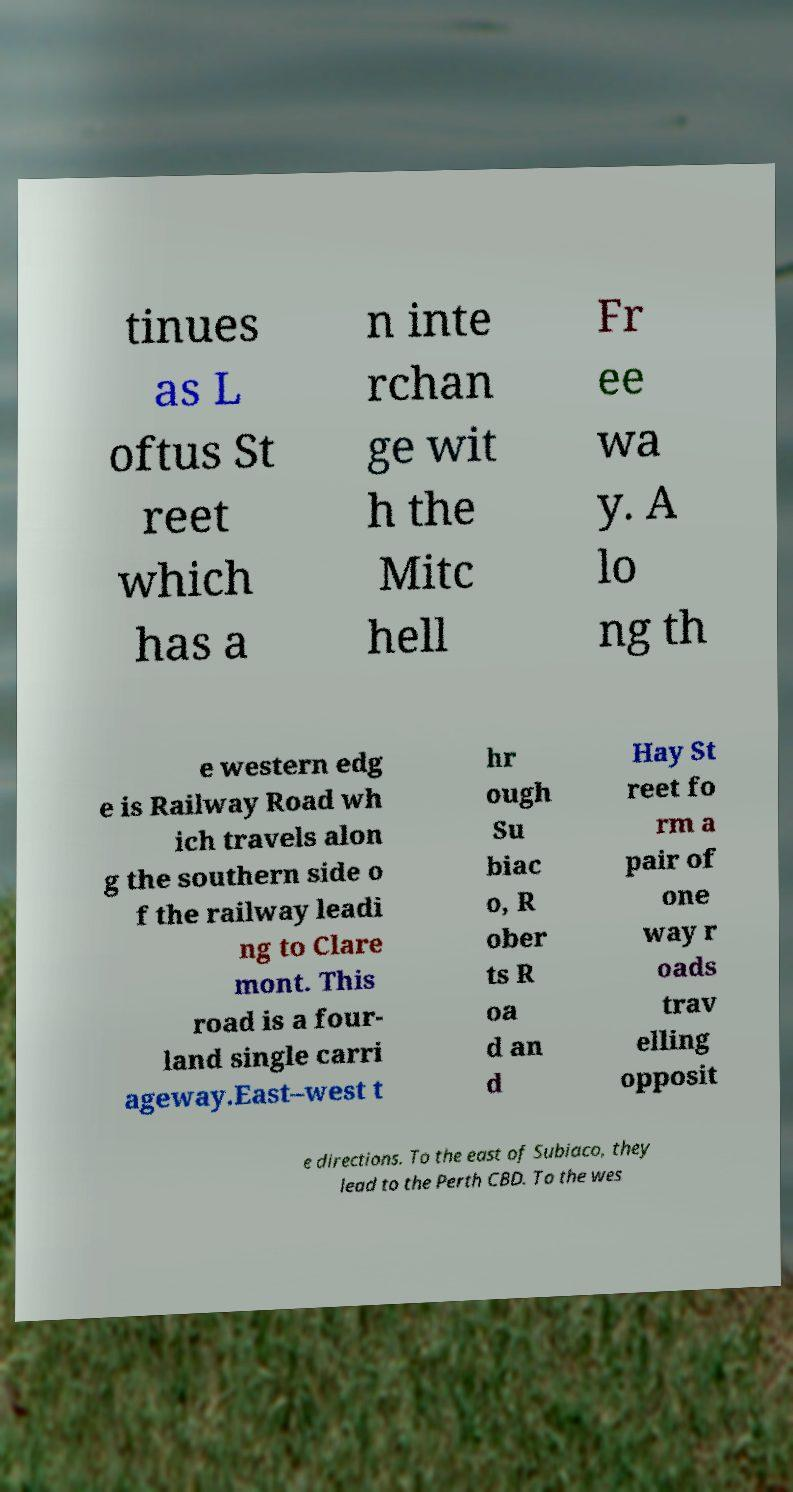Please identify and transcribe the text found in this image. tinues as L oftus St reet which has a n inte rchan ge wit h the Mitc hell Fr ee wa y. A lo ng th e western edg e is Railway Road wh ich travels alon g the southern side o f the railway leadi ng to Clare mont. This road is a four- land single carri ageway.East–west t hr ough Su biac o, R ober ts R oa d an d Hay St reet fo rm a pair of one way r oads trav elling opposit e directions. To the east of Subiaco, they lead to the Perth CBD. To the wes 